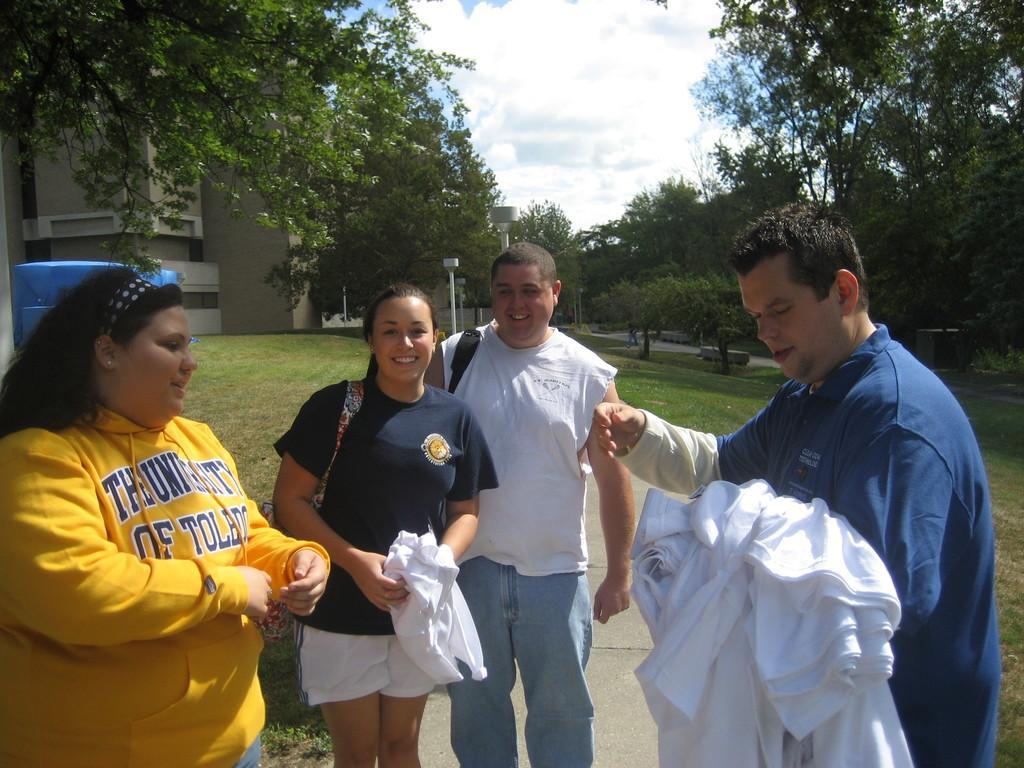Describe this image in one or two sentences. In this picture we can observe four members. Two of them are women and the remaining two are men. We can observe white color clothes in the hand of a man wearing blue color dress. We can observe some grass on the ground. In the background there are trees, building and a sky with some clouds. 